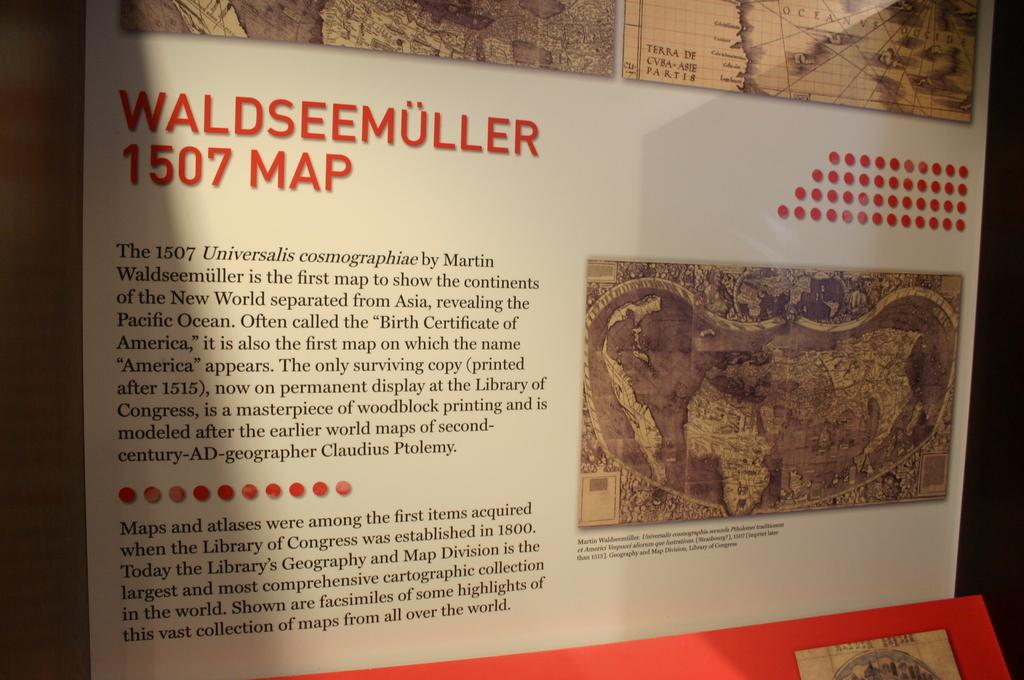<image>
Describe the image concisely. A Map of 1507 Waldseemuller is hanging on a board. 